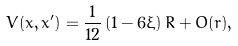Convert formula to latex. <formula><loc_0><loc_0><loc_500><loc_500>V ( x , x ^ { \prime } ) = \frac { 1 } { 1 2 } \left ( 1 - 6 \xi \right ) R + O ( r ) ,</formula> 